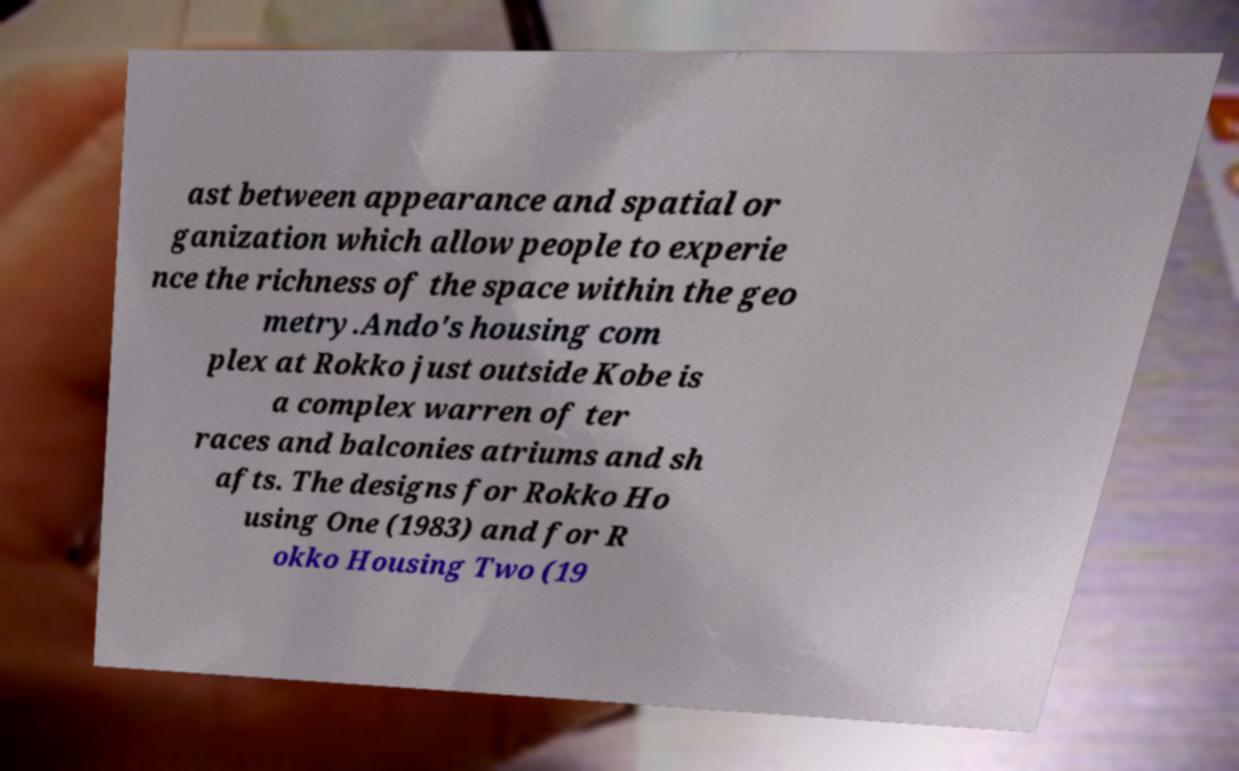I need the written content from this picture converted into text. Can you do that? ast between appearance and spatial or ganization which allow people to experie nce the richness of the space within the geo metry.Ando's housing com plex at Rokko just outside Kobe is a complex warren of ter races and balconies atriums and sh afts. The designs for Rokko Ho using One (1983) and for R okko Housing Two (19 